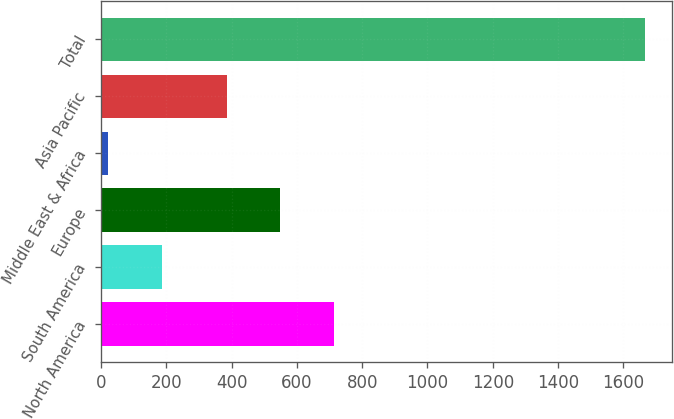Convert chart. <chart><loc_0><loc_0><loc_500><loc_500><bar_chart><fcel>North America<fcel>South America<fcel>Europe<fcel>Middle East & Africa<fcel>Asia Pacific<fcel>Total<nl><fcel>715<fcel>186.5<fcel>549.5<fcel>22<fcel>385<fcel>1667<nl></chart> 